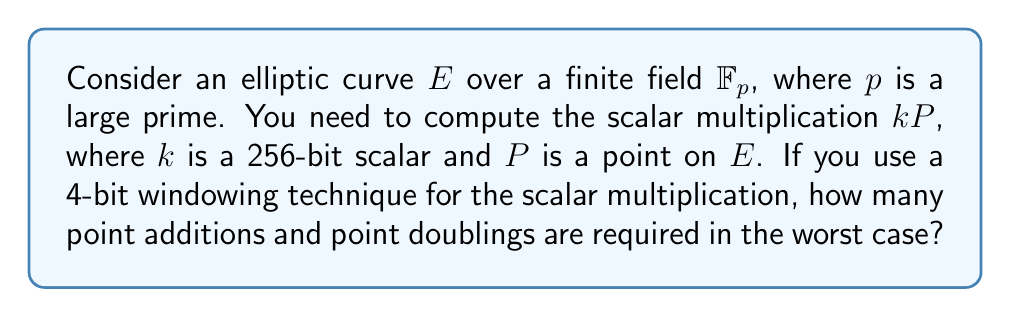Solve this math problem. Let's approach this step-by-step:

1) In a 4-bit windowing technique, we process the scalar $k$ in 4-bit chunks.

2) For a 256-bit scalar, we have $\lceil 256/4 \rceil = 64$ windows.

3) Pre-computation phase:
   - We need to pre-compute $2^4 - 1 = 15$ points (1P, 2P, 3P, ..., 15P).
   - This requires 14 point additions.

4) Main computation phase:
   - We perform a point doubling for each bit (256 times).
   - We perform a point addition for each non-zero window (worst case: all 64 windows are non-zero).

5) Total operations:
   - Point doublings: 256
   - Point additions: 14 (pre-computation) + 64 (main computation) = 78

Therefore, in the worst case, we need 256 point doublings and 78 point additions.
Answer: 256 point doublings, 78 point additions 